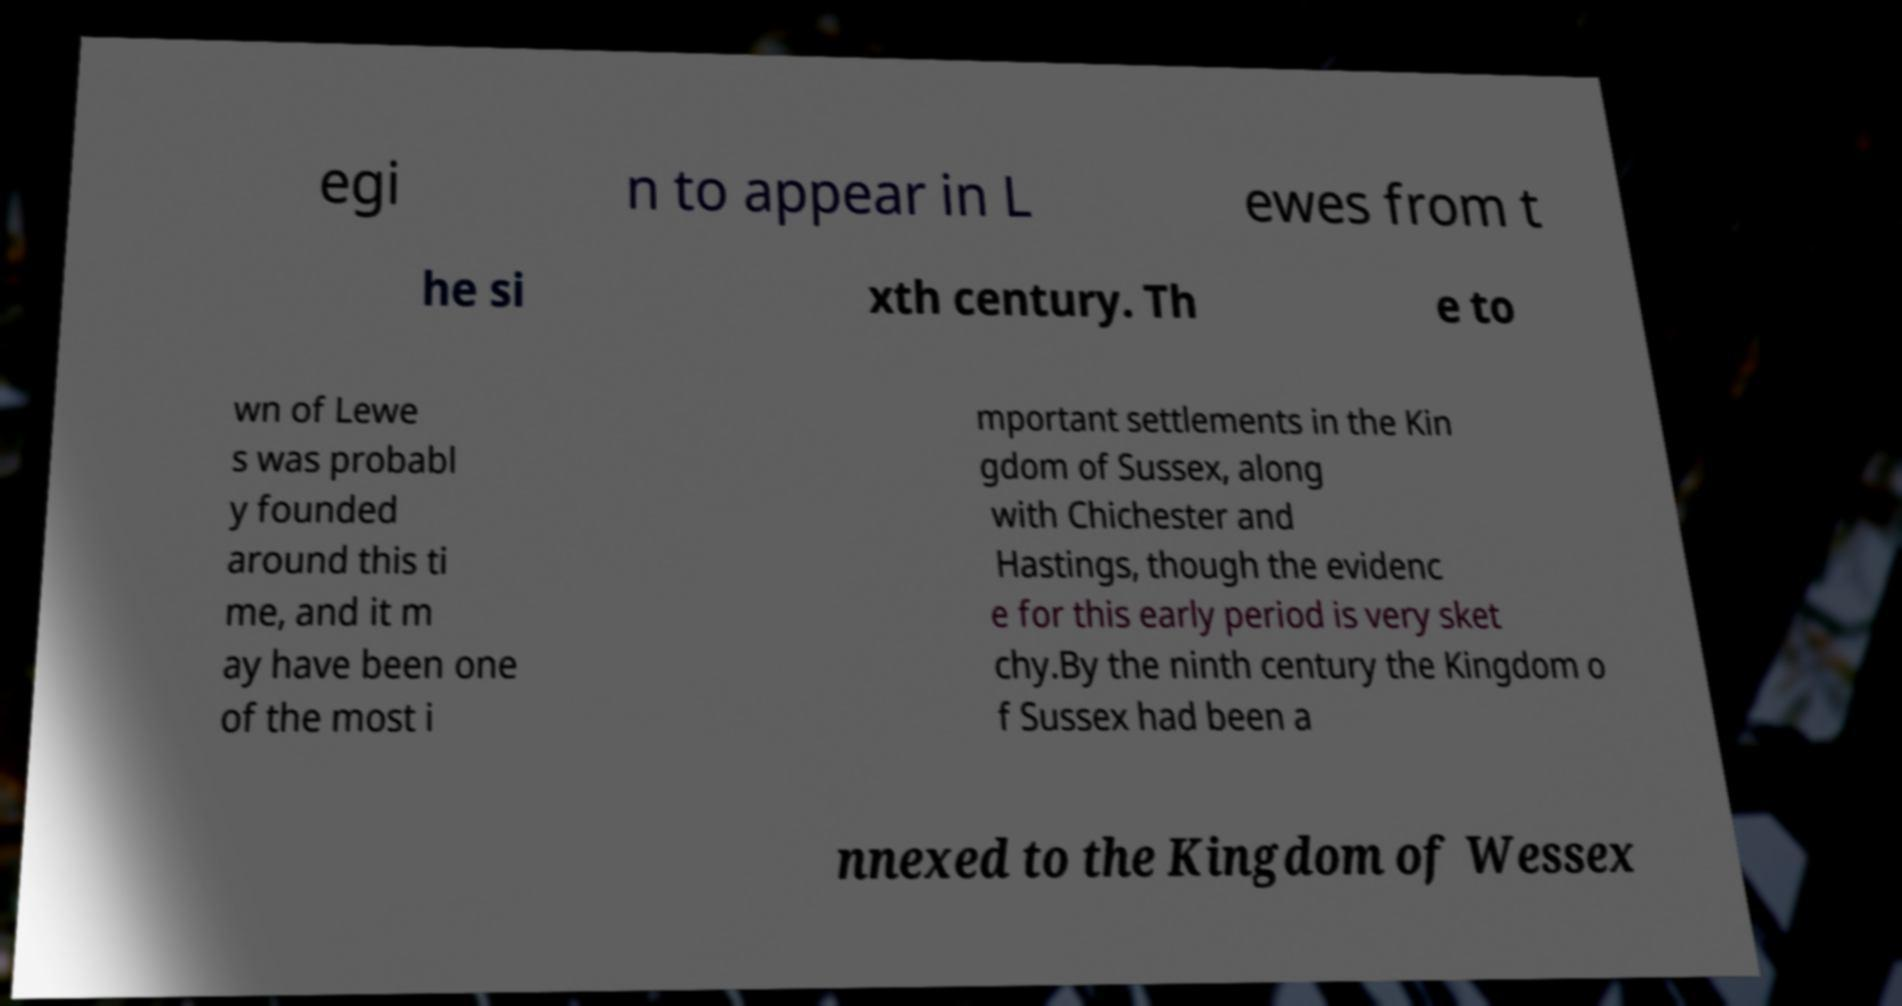For documentation purposes, I need the text within this image transcribed. Could you provide that? egi n to appear in L ewes from t he si xth century. Th e to wn of Lewe s was probabl y founded around this ti me, and it m ay have been one of the most i mportant settlements in the Kin gdom of Sussex, along with Chichester and Hastings, though the evidenc e for this early period is very sket chy.By the ninth century the Kingdom o f Sussex had been a nnexed to the Kingdom of Wessex 